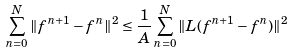Convert formula to latex. <formula><loc_0><loc_0><loc_500><loc_500>\sum _ { n = 0 } ^ { N } \| f ^ { n + 1 } - f ^ { n } \| ^ { 2 } \leq \frac { 1 } { A } \sum _ { n = 0 } ^ { N } \| L ( f ^ { n + 1 } - f ^ { n } ) \| ^ { 2 }</formula> 